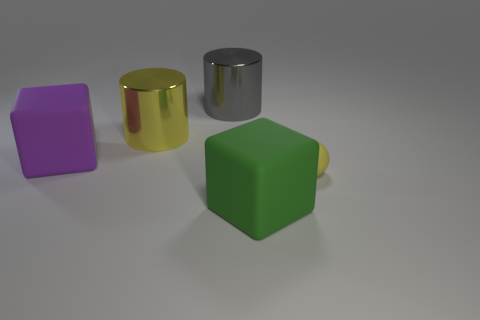Do the gray shiny object and the matte sphere have the same size? The gray shiny object appears to be a cylinder and the matte object is a sphere. While it's challenging to determine scale without a reference, the cylinder seems to be taller than the sphere's diameter, indicating they do not have the same size. 